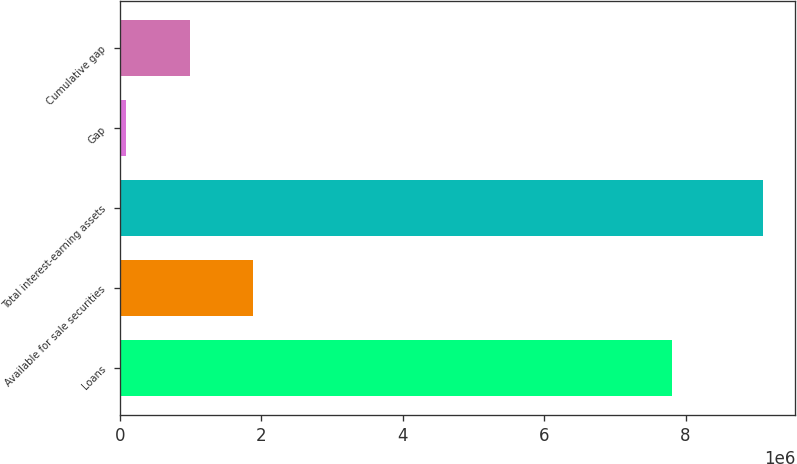<chart> <loc_0><loc_0><loc_500><loc_500><bar_chart><fcel>Loans<fcel>Available for sale securities<fcel>Total interest-earning assets<fcel>Gap<fcel>Cumulative gap<nl><fcel>7.80262e+06<fcel>1.89083e+06<fcel>9.09666e+06<fcel>89376<fcel>990104<nl></chart> 